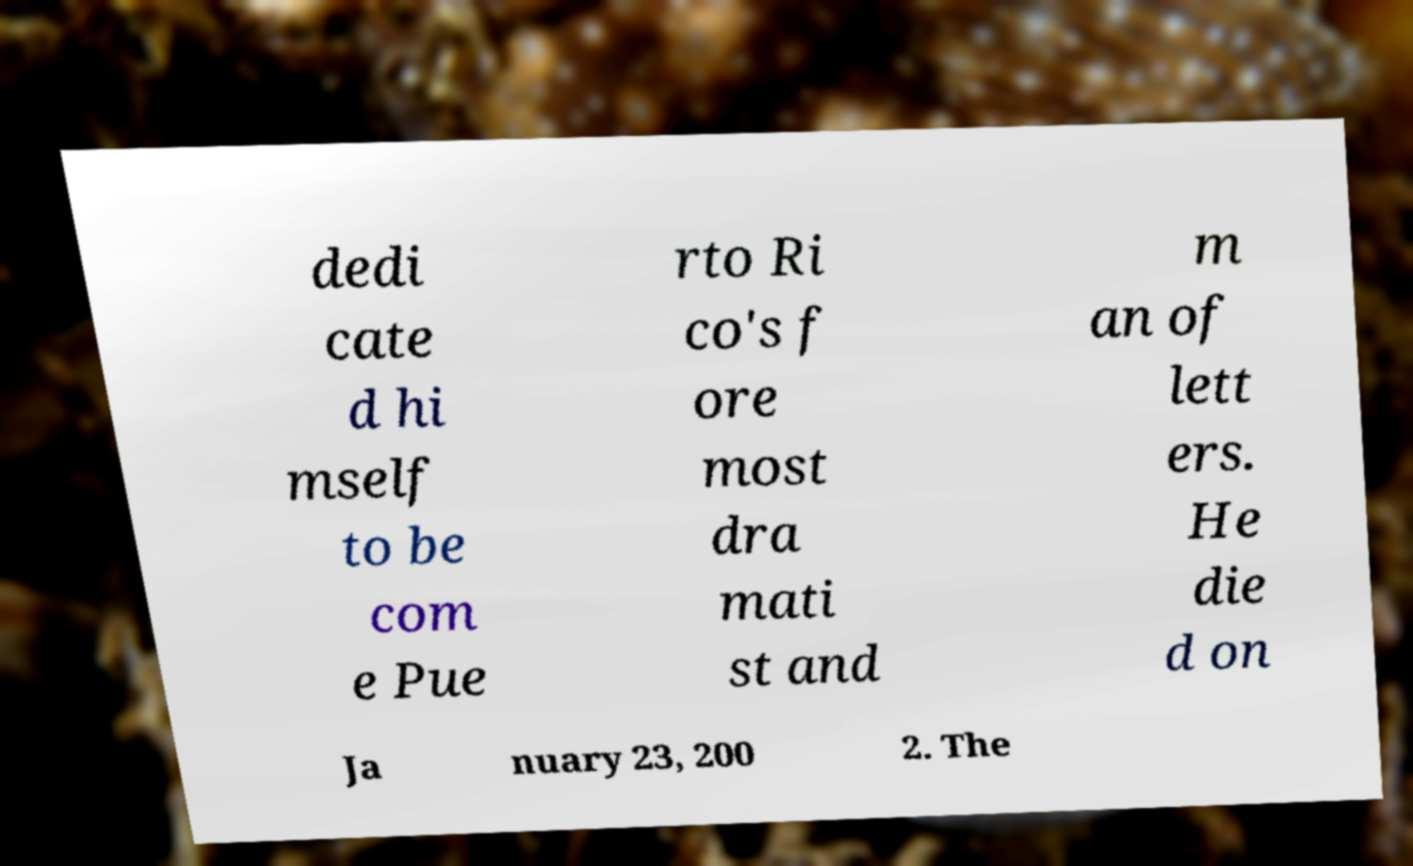What messages or text are displayed in this image? I need them in a readable, typed format. dedi cate d hi mself to be com e Pue rto Ri co's f ore most dra mati st and m an of lett ers. He die d on Ja nuary 23, 200 2. The 